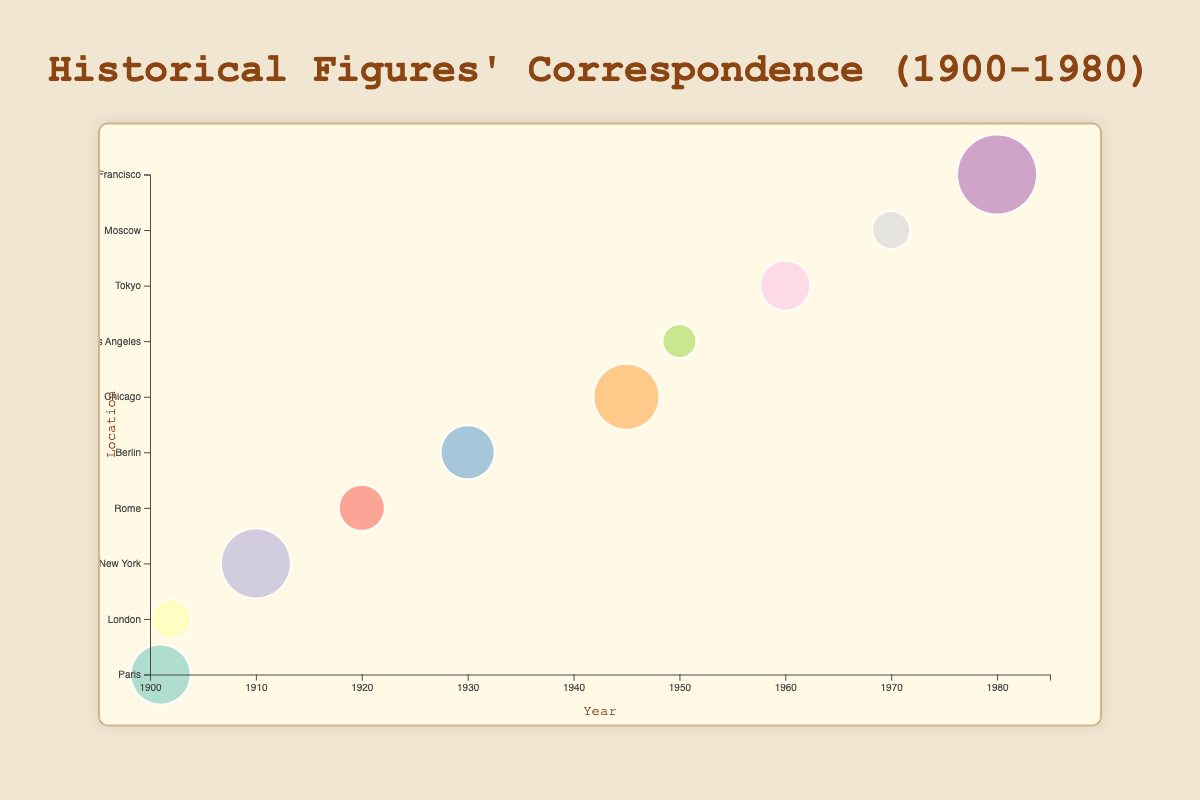What is the title of the bubble chart? The title is displayed prominently at the top of the chart in a larger font size. It provides a quick summary of the data being visualized. The title reads "Historical Figures' Correspondence (1900-1980)."
Answer: Historical Figures' Correspondence (1900-1980) Which location has the largest bubble representing the highest correspondence count? The bubble representing Stephen Hawking in San Francisco has the largest size, indicating the highest correspondence count among all data points.
Answer: San Francisco How many historical figures are represented in the chart? Each bubble corresponds to a historical figure, and visual inspection reveals that there are 10 distinct bubbles for different individuals.
Answer: 10 In which year did Nikola Tesla have a correspondence count, and what was the count? By locating the bubble for Nikola Tesla on the chart, it is clear that it is placed at the year 1910, with a correspondence count of 30.
Answer: 1910, 30 Which historical figure had the smallest correspondence count, and what is the value? The smallest bubble on the chart corresponds to Richard Feynman in Los Angeles, with a correspondence count of 12.
Answer: Richard Feynman, 12 How does the correspondence count for Albert Einstein compare to that of Andrei Sakharov? By observing the size of the bubbles for both Albert Einstein and Andrei Sakharov, we see that Albert Einstein has a larger bubble with a correspondence count of 22, whereas Andrei Sakharov has a bubble indicating a correspondence count of 14.
Answer: Albert Einstein has a higher count What is the difference in correspondence counts between the year with the maximum count and the year with the minimum count? The maximum correspondence count is 35 (Stephen Hawking, 1980), and the minimum correspondence count is 12 (Richard Feynman, 1950). The difference is 35 - 12.
Answer: 23 List the locations and corresponding historical figures who had a correspondence count greater than 20. Bubbles with correspondence counts greater than 20 are for Marie Curie (Paris), Nikola Tesla (New York), Enrico Fermi (Chicago), and Stephen Hawking (San Francisco).
Answer: Paris, New York, Chicago, San Francisco What is the average correspondence count of all the historical figures displayed in the chart? Summing all correspondence counts: 25 (Marie Curie) + 15 (Charles Darwin) + 30 (Nikola Tesla) + 18 (Guglielmo Marconi) + 22 (Albert Einstein) + 28 (Enrico Fermi) + 12 (Richard Feynman) + 20 (Yukawa Hideki) + 14 (Andrei Sakharov) + 35 (Stephen Hawking) = 219. Average is 219 / 10.
Answer: 21.9 